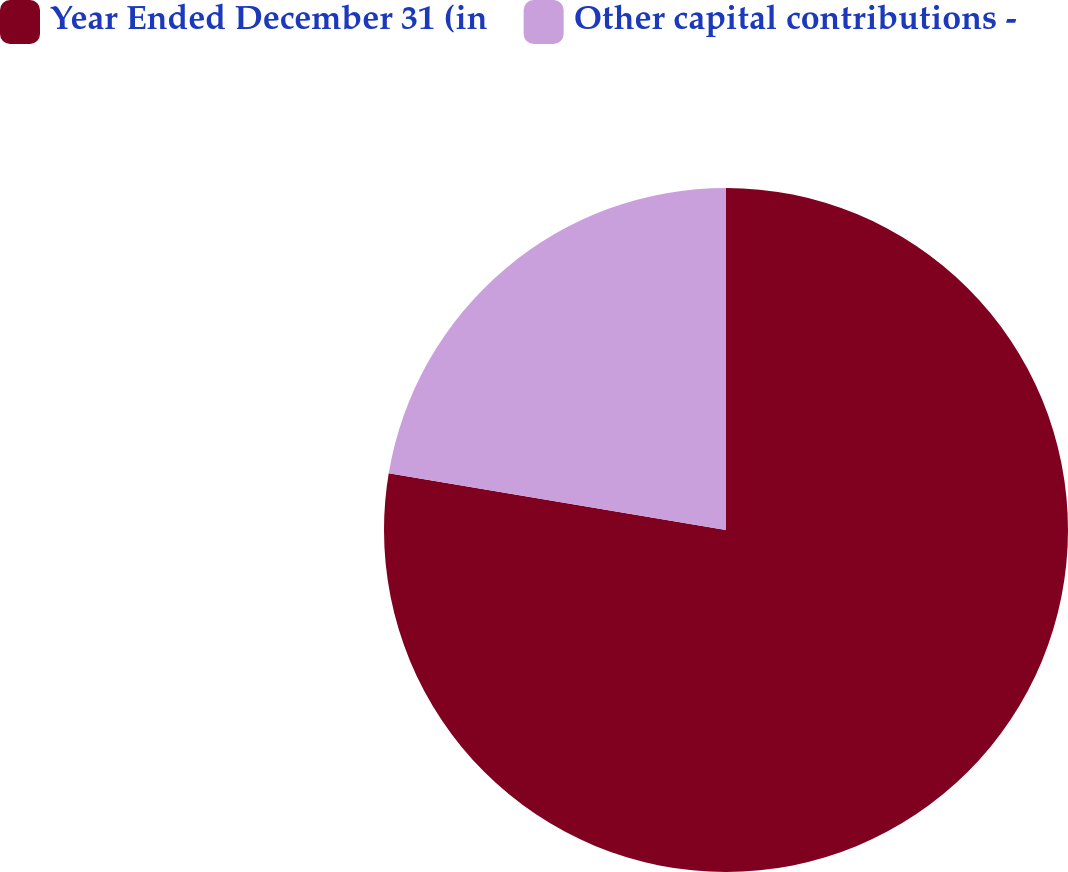Convert chart to OTSL. <chart><loc_0><loc_0><loc_500><loc_500><pie_chart><fcel>Year Ended December 31 (in<fcel>Other capital contributions -<nl><fcel>77.65%<fcel>22.35%<nl></chart> 